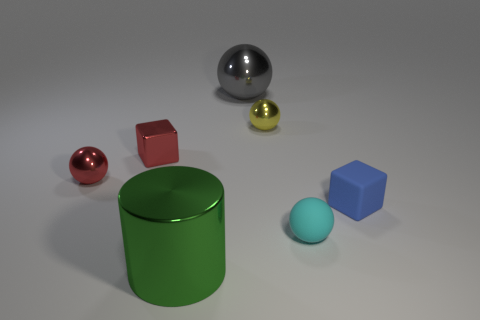What number of tiny metallic spheres have the same color as the shiny block?
Offer a terse response. 1. What number of green rubber blocks are there?
Provide a short and direct response. 0. What number of gray balls have the same material as the cylinder?
Offer a very short reply. 1. What is the size of the gray shiny object that is the same shape as the small cyan matte thing?
Make the answer very short. Large. What is the material of the tiny yellow object?
Your answer should be compact. Metal. There is a tiny blue block that is in front of the red object that is behind the tiny shiny sphere left of the metal cylinder; what is it made of?
Your answer should be compact. Rubber. Is there any other thing that has the same shape as the green shiny object?
Provide a short and direct response. No. What is the color of the big metal thing that is the same shape as the small cyan matte thing?
Offer a very short reply. Gray. There is a rubber thing that is in front of the small blue thing; is it the same color as the block to the right of the big green object?
Ensure brevity in your answer.  No. Is the number of metallic things that are in front of the cyan matte sphere greater than the number of brown metallic cubes?
Provide a short and direct response. Yes. 